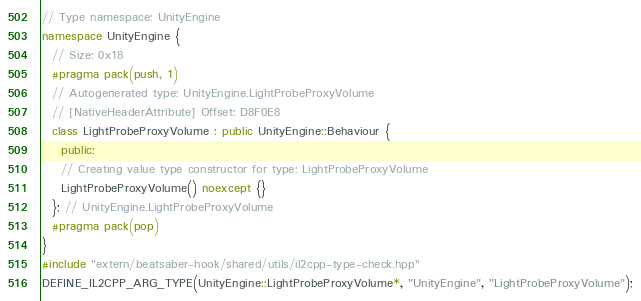Convert code to text. <code><loc_0><loc_0><loc_500><loc_500><_C++_>// Type namespace: UnityEngine
namespace UnityEngine {
  // Size: 0x18
  #pragma pack(push, 1)
  // Autogenerated type: UnityEngine.LightProbeProxyVolume
  // [NativeHeaderAttribute] Offset: D8F0E8
  class LightProbeProxyVolume : public UnityEngine::Behaviour {
    public:
    // Creating value type constructor for type: LightProbeProxyVolume
    LightProbeProxyVolume() noexcept {}
  }; // UnityEngine.LightProbeProxyVolume
  #pragma pack(pop)
}
#include "extern/beatsaber-hook/shared/utils/il2cpp-type-check.hpp"
DEFINE_IL2CPP_ARG_TYPE(UnityEngine::LightProbeProxyVolume*, "UnityEngine", "LightProbeProxyVolume");
</code> 